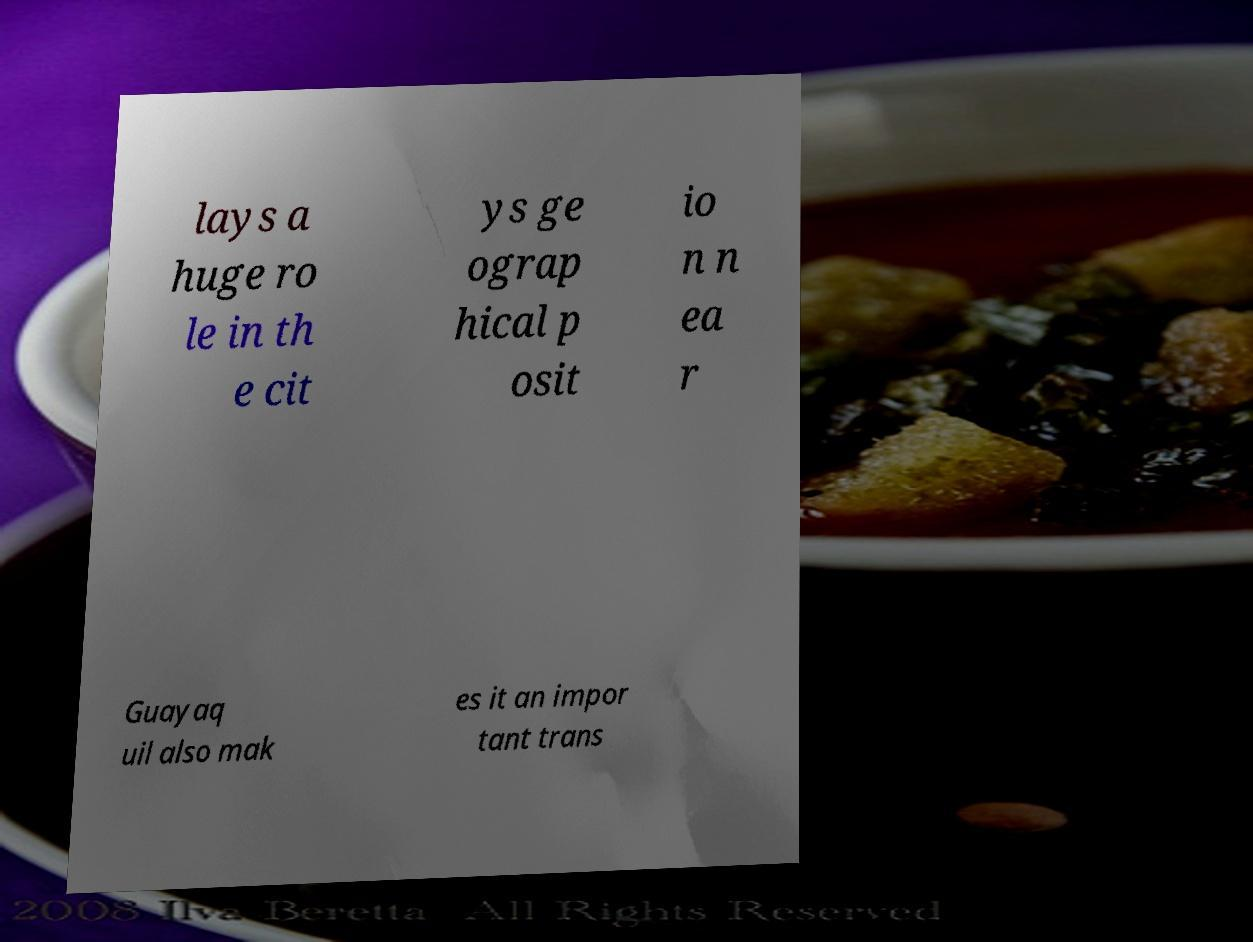What messages or text are displayed in this image? I need them in a readable, typed format. lays a huge ro le in th e cit ys ge ograp hical p osit io n n ea r Guayaq uil also mak es it an impor tant trans 